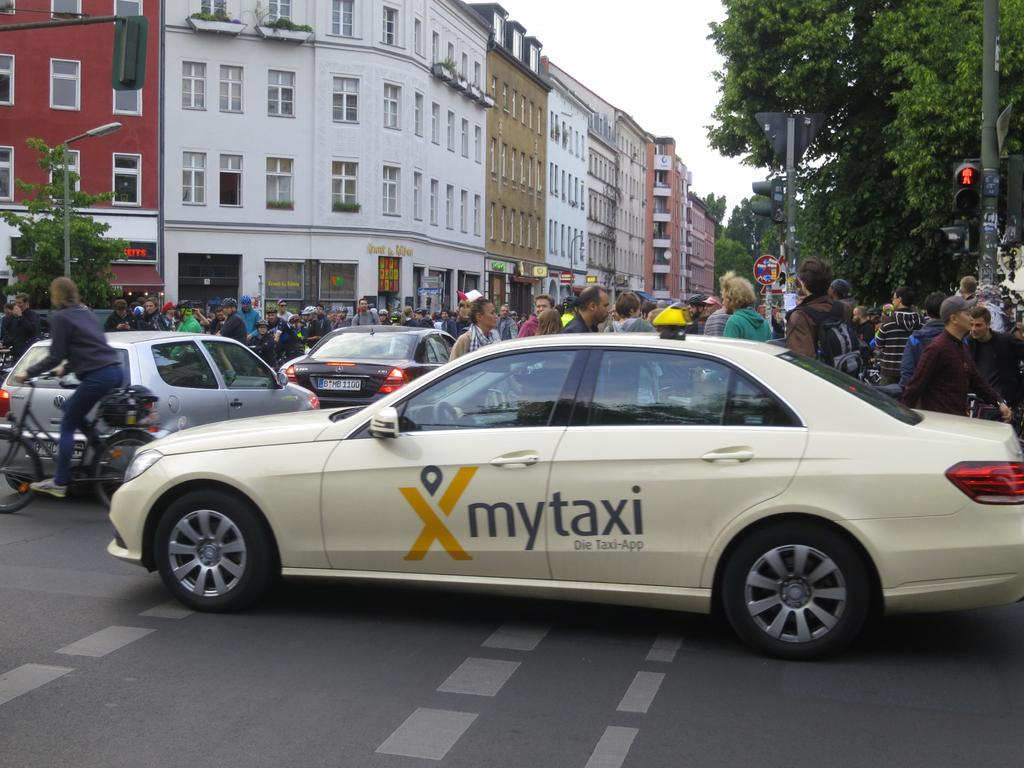<image>
Create a compact narrative representing the image presented. A cream colored car from mytaxi is in the intersection 